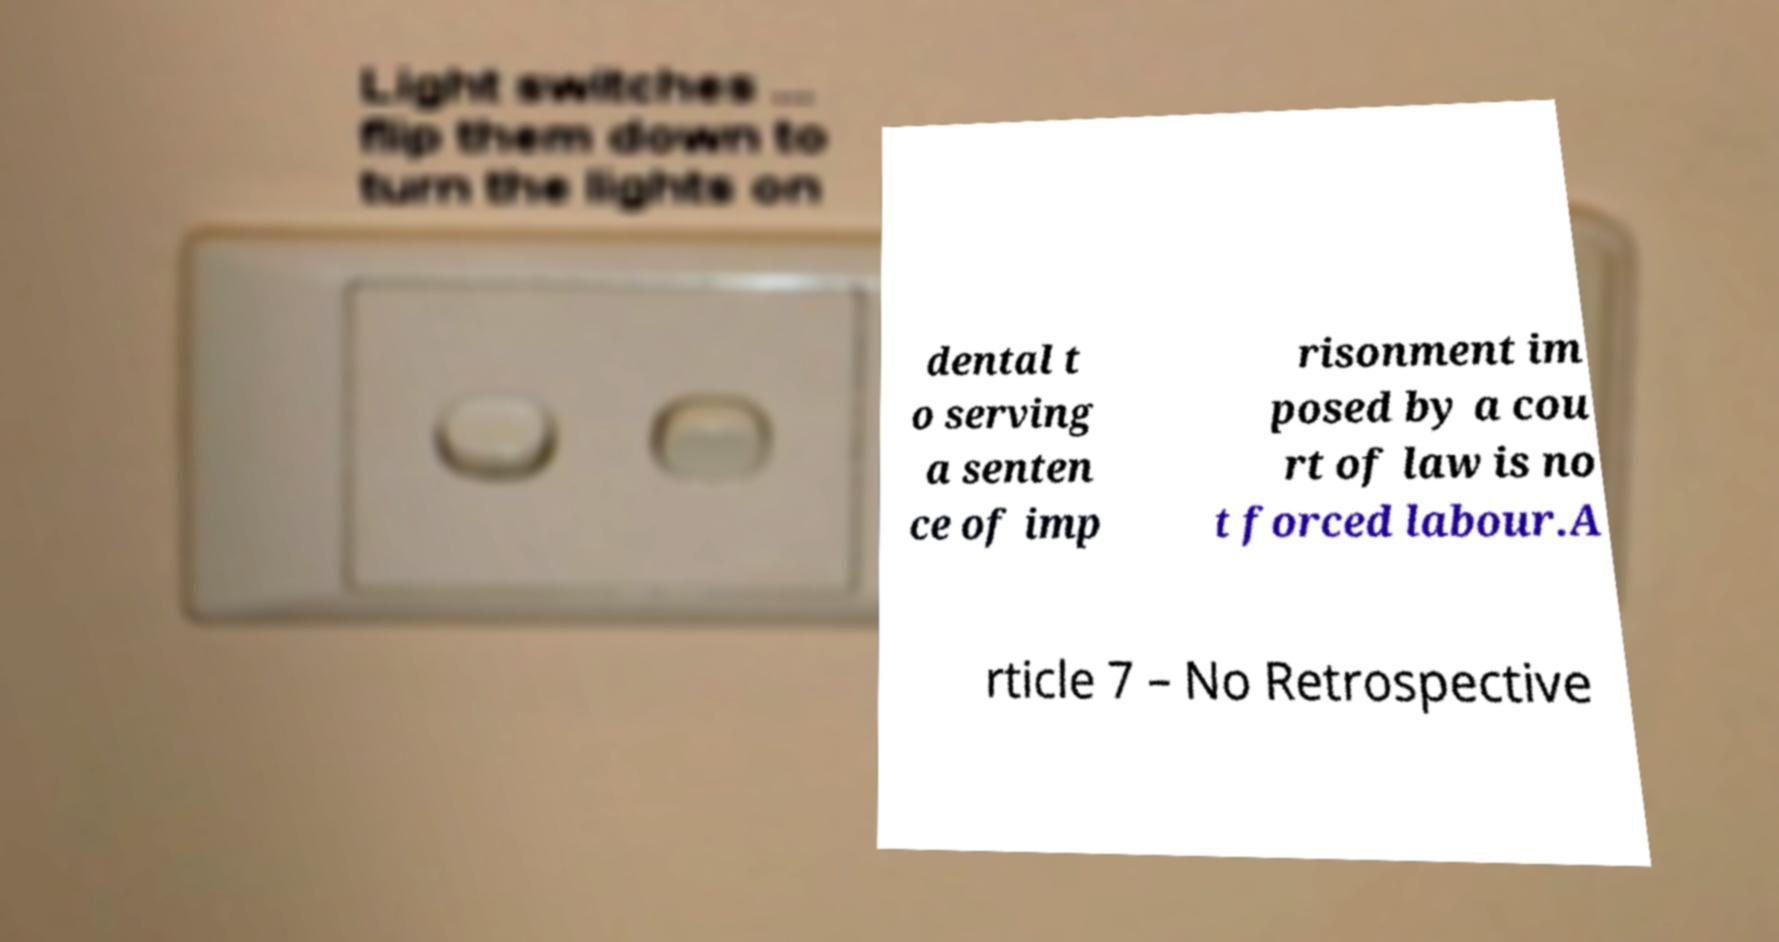Please read and relay the text visible in this image. What does it say? dental t o serving a senten ce of imp risonment im posed by a cou rt of law is no t forced labour.A rticle 7 – No Retrospective 